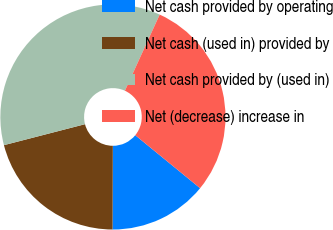<chart> <loc_0><loc_0><loc_500><loc_500><pie_chart><fcel>Net cash provided by operating<fcel>Net cash (used in) provided by<fcel>Net cash provided by (used in)<fcel>Net (decrease) increase in<nl><fcel>14.15%<fcel>20.92%<fcel>35.85%<fcel>29.08%<nl></chart> 